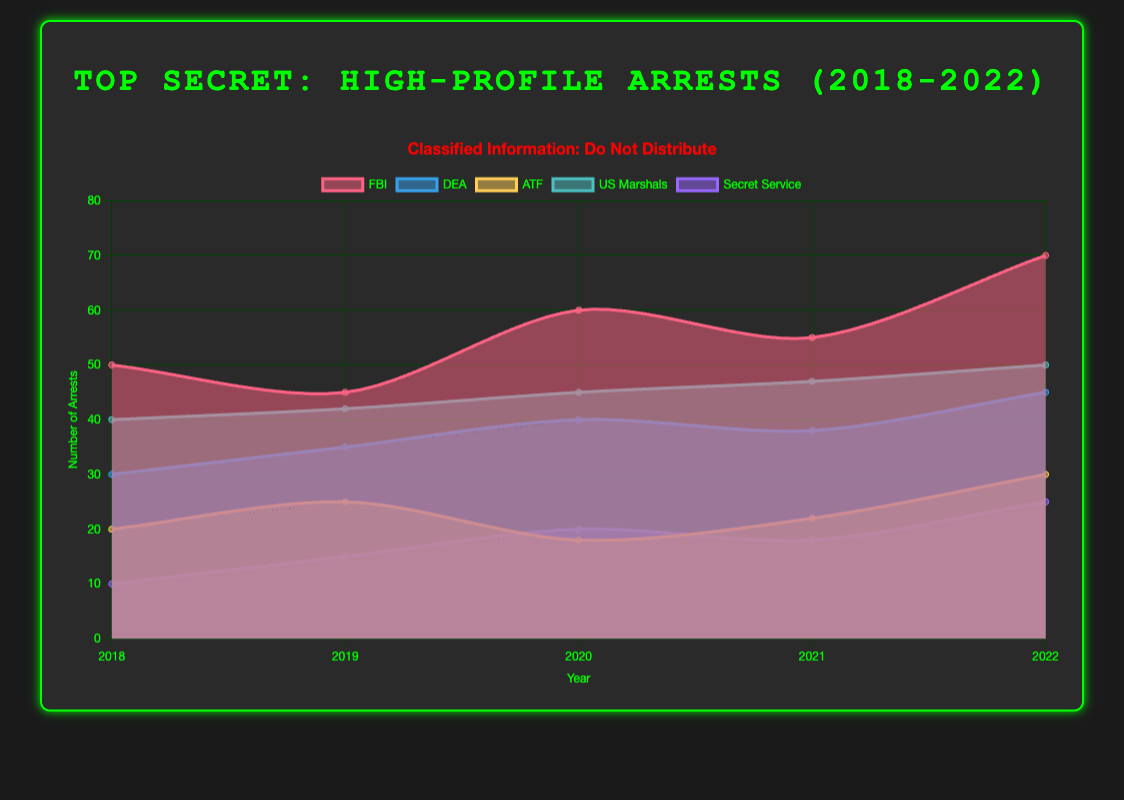How many departments are plotted on the chart? By examining the legend of the chart, you can count the number of distinct labels. The labels "FBI", "DEA", "ATF", "US Marshals", and "Secret Service" are visible.
Answer: 5 Which department had the highest number of high-profile arrests in 2022? Look at the data points for 2022 and identify the highest value. The highest value belongs to the FBI with 70 arrests.
Answer: FBI What is the sum of the high-profile arrests for the ATF from 2018 to 2022? To find the total number of arrests for the ATF, simply sum the values from each year: 20 (2018) + 25 (2019) + 18 (2020) + 22 (2021) + 30 (2022) = 115.
Answer: 115 In which year did the DEA have its highest number of arrests, and how many arrests were there? Look at the DEA's data trend across the years and identify the highest value and the corresponding year. DEA had its highest number of arrests in 2022 with 45 arrests.
Answer: 2022, 45 Did the high-profile arrests by the US Marshals increase, decrease, or remain the same from 2019 to 2020? Compare the data values for the US Marshals from 2019 and 2020. In 2019, the number is 42, and in 2020, the number is 45. There is an increase.
Answer: Increase Which two departments had the closest number of high-profile arrests in 2021? Compare the data points for 2021 and find the two closest values. In 2021, DEA had 38 arrests and ATF had 22 arrests, meaning the closest comparison would be US Marshals (47) and Secret Service (18). Thus, the fifth and fourth closest are the correct answer: ATF (22) and Secret Service (18).
Answer: ATF and Secret Service What was the average number of high-profile arrests for the Secret Service over the five years? To find the average, sum the number of arrests from 2018 to 2022, and then divide by 5. Thus, the calculation is (10 + 15 + 20 + 18 + 25) / 5 = 17.6.
Answer: 17.6 Which year had the lowest total number of high-profile arrests across all departments? Calculate the sum of arrests for each year and compare them. Yearly totals are: 2018: 150, 2019: 162, 2020: 183, 2021: 180, 2022: 220. The year with the lowest total is 2018 with 150 arrests.
Answer: 2018 Was the trend of high-profile arrests for the FBI increasing, decreasing, or fluctuating over the years? Review the FBI's data over the years: 50 (2018), 45 (2019), 60 (2020), 55 (2021), and 70 (2022). The trend initially fluctuated but overall shows an increase from 50 to 70.
Answer: Increasing 